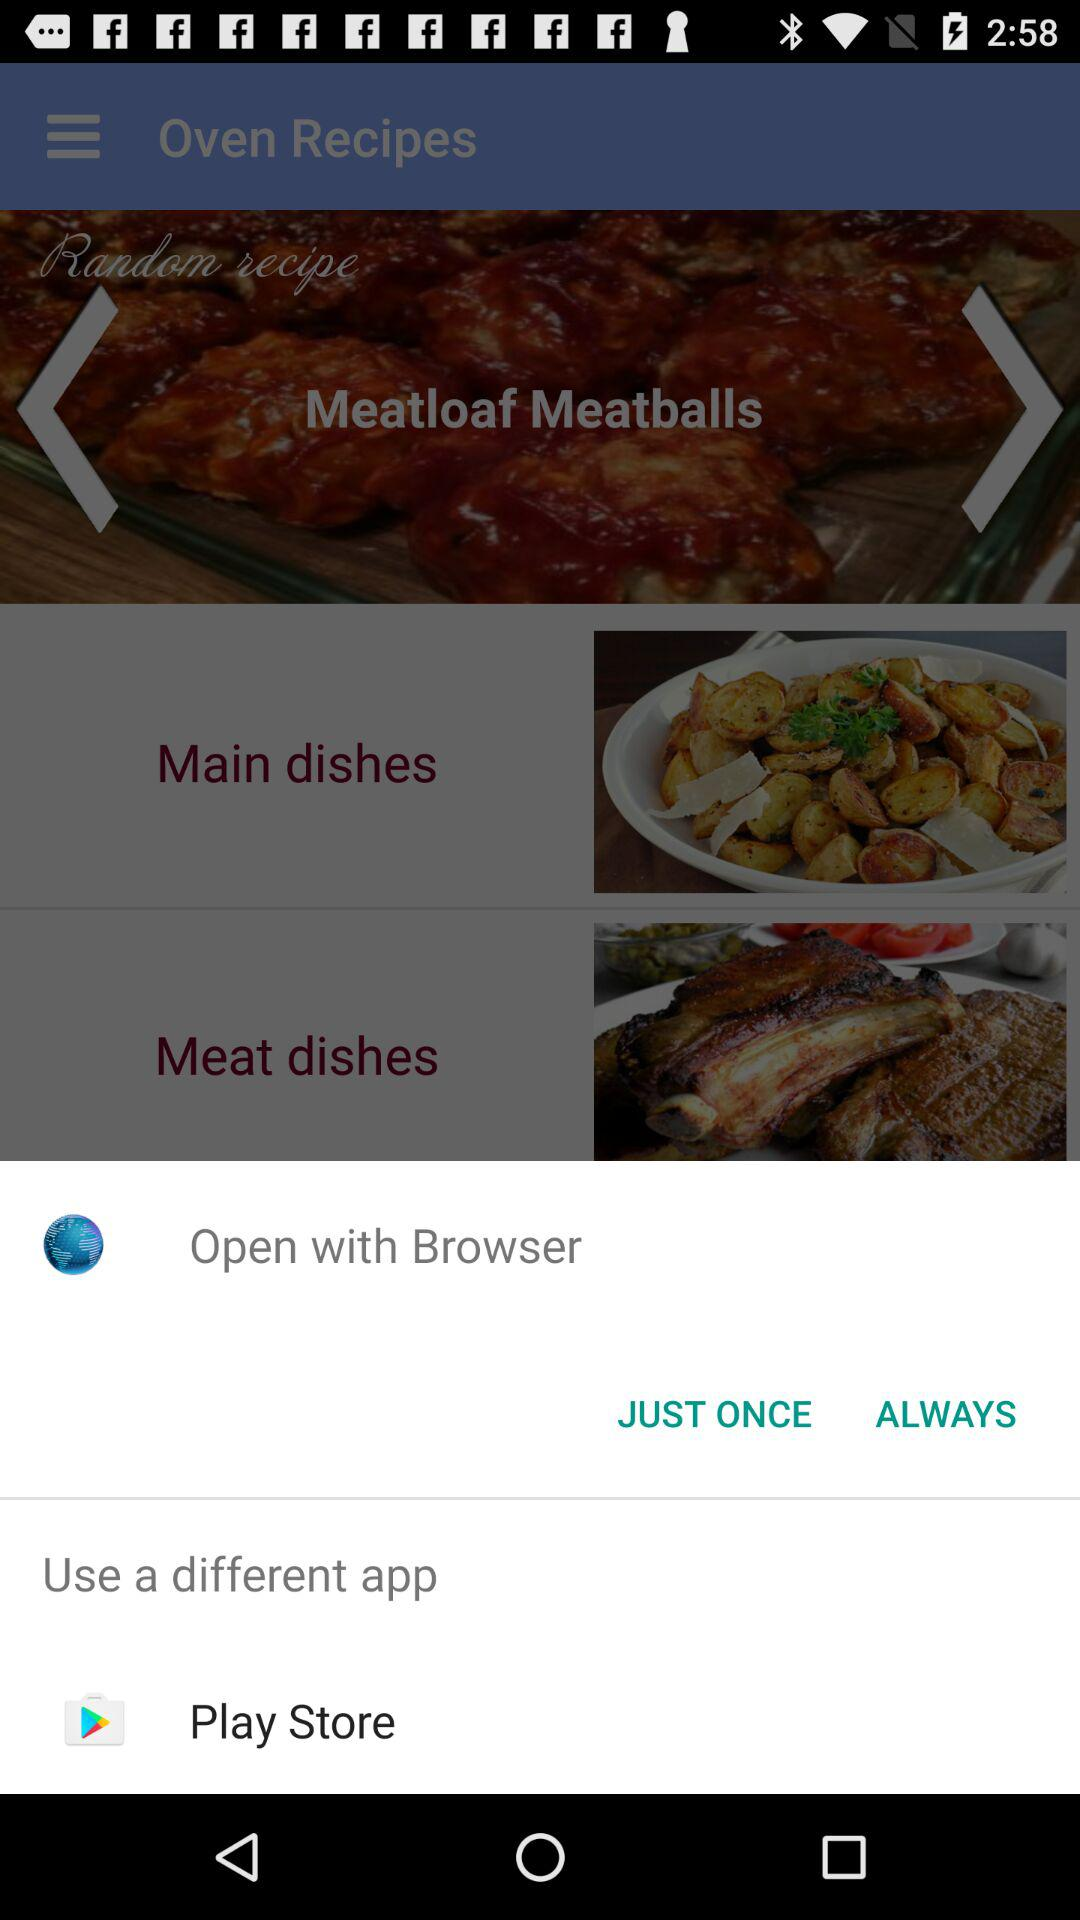Through which application can it be opened? It can be opened through "Browser" and "Play Store". 